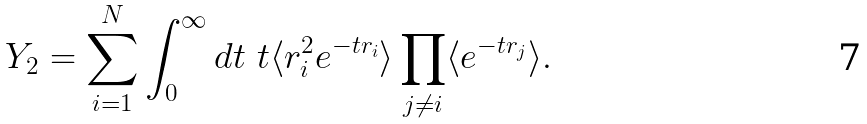Convert formula to latex. <formula><loc_0><loc_0><loc_500><loc_500>Y _ { 2 } = \sum _ { i = 1 } ^ { N } \int _ { 0 } ^ { \infty } d t \ t \langle r _ { i } ^ { 2 } e ^ { - t r _ { i } } \rangle \prod _ { j \neq i } \langle e ^ { - t r _ { j } } \rangle .</formula> 